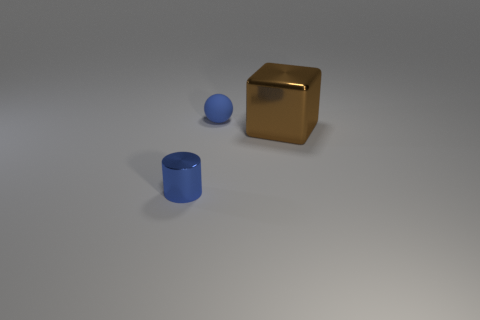Add 3 tiny things. How many objects exist? 6 Subtract all blocks. How many objects are left? 2 Subtract 0 blue blocks. How many objects are left? 3 Subtract all small blue metal cylinders. Subtract all brown objects. How many objects are left? 1 Add 3 rubber objects. How many rubber objects are left? 4 Add 1 large purple matte objects. How many large purple matte objects exist? 1 